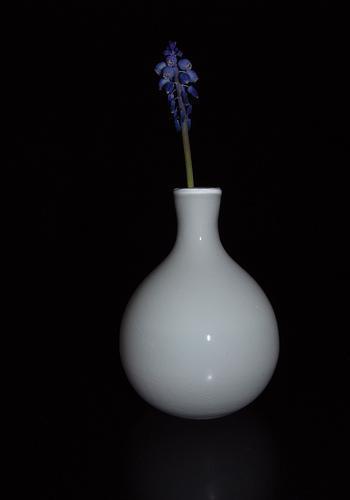How many flowers are in the vase?
Give a very brief answer. 1. How many vases are there?
Give a very brief answer. 1. How many  flowers are in the vase?
Give a very brief answer. 1. How many items are red?
Give a very brief answer. 0. 